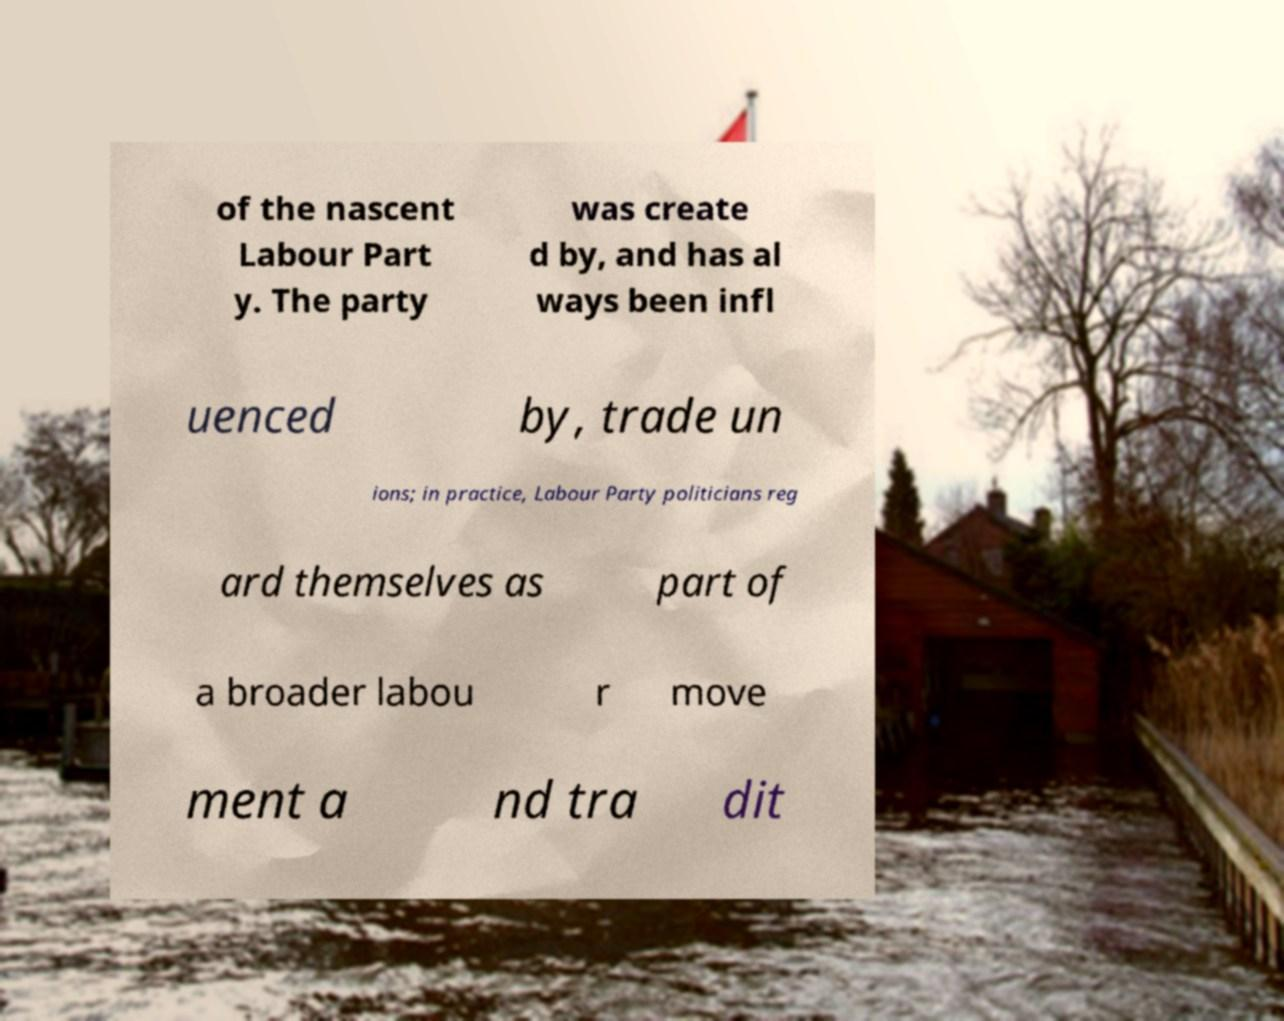What messages or text are displayed in this image? I need them in a readable, typed format. of the nascent Labour Part y. The party was create d by, and has al ways been infl uenced by, trade un ions; in practice, Labour Party politicians reg ard themselves as part of a broader labou r move ment a nd tra dit 